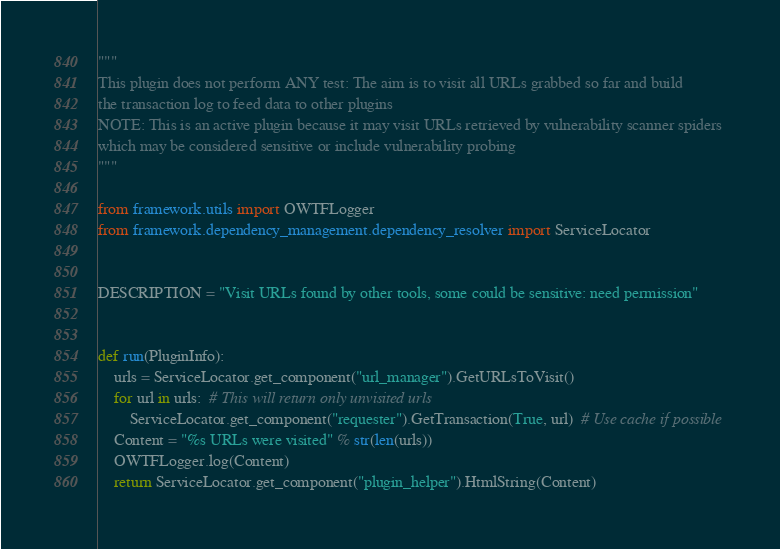Convert code to text. <code><loc_0><loc_0><loc_500><loc_500><_Python_>"""
This plugin does not perform ANY test: The aim is to visit all URLs grabbed so far and build
the transaction log to feed data to other plugins
NOTE: This is an active plugin because it may visit URLs retrieved by vulnerability scanner spiders
which may be considered sensitive or include vulnerability probing
"""

from framework.utils import OWTFLogger
from framework.dependency_management.dependency_resolver import ServiceLocator


DESCRIPTION = "Visit URLs found by other tools, some could be sensitive: need permission"


def run(PluginInfo):
    urls = ServiceLocator.get_component("url_manager").GetURLsToVisit()
    for url in urls:  # This will return only unvisited urls
        ServiceLocator.get_component("requester").GetTransaction(True, url)  # Use cache if possible
    Content = "%s URLs were visited" % str(len(urls))
    OWTFLogger.log(Content)
    return ServiceLocator.get_component("plugin_helper").HtmlString(Content)
</code> 